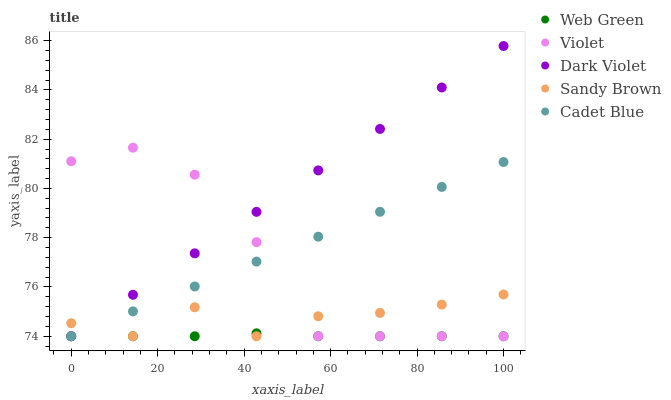Does Web Green have the minimum area under the curve?
Answer yes or no. Yes. Does Dark Violet have the maximum area under the curve?
Answer yes or no. Yes. Does Sandy Brown have the minimum area under the curve?
Answer yes or no. No. Does Sandy Brown have the maximum area under the curve?
Answer yes or no. No. Is Dark Violet the smoothest?
Answer yes or no. Yes. Is Violet the roughest?
Answer yes or no. Yes. Is Sandy Brown the smoothest?
Answer yes or no. No. Is Sandy Brown the roughest?
Answer yes or no. No. Does Cadet Blue have the lowest value?
Answer yes or no. Yes. Does Dark Violet have the highest value?
Answer yes or no. Yes. Does Sandy Brown have the highest value?
Answer yes or no. No. Does Cadet Blue intersect Violet?
Answer yes or no. Yes. Is Cadet Blue less than Violet?
Answer yes or no. No. Is Cadet Blue greater than Violet?
Answer yes or no. No. 